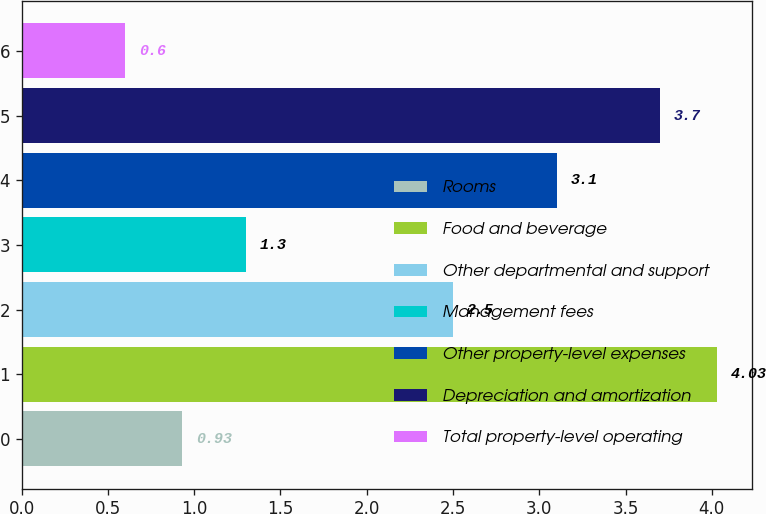Convert chart. <chart><loc_0><loc_0><loc_500><loc_500><bar_chart><fcel>Rooms<fcel>Food and beverage<fcel>Other departmental and support<fcel>Management fees<fcel>Other property-level expenses<fcel>Depreciation and amortization<fcel>Total property-level operating<nl><fcel>0.93<fcel>4.03<fcel>2.5<fcel>1.3<fcel>3.1<fcel>3.7<fcel>0.6<nl></chart> 